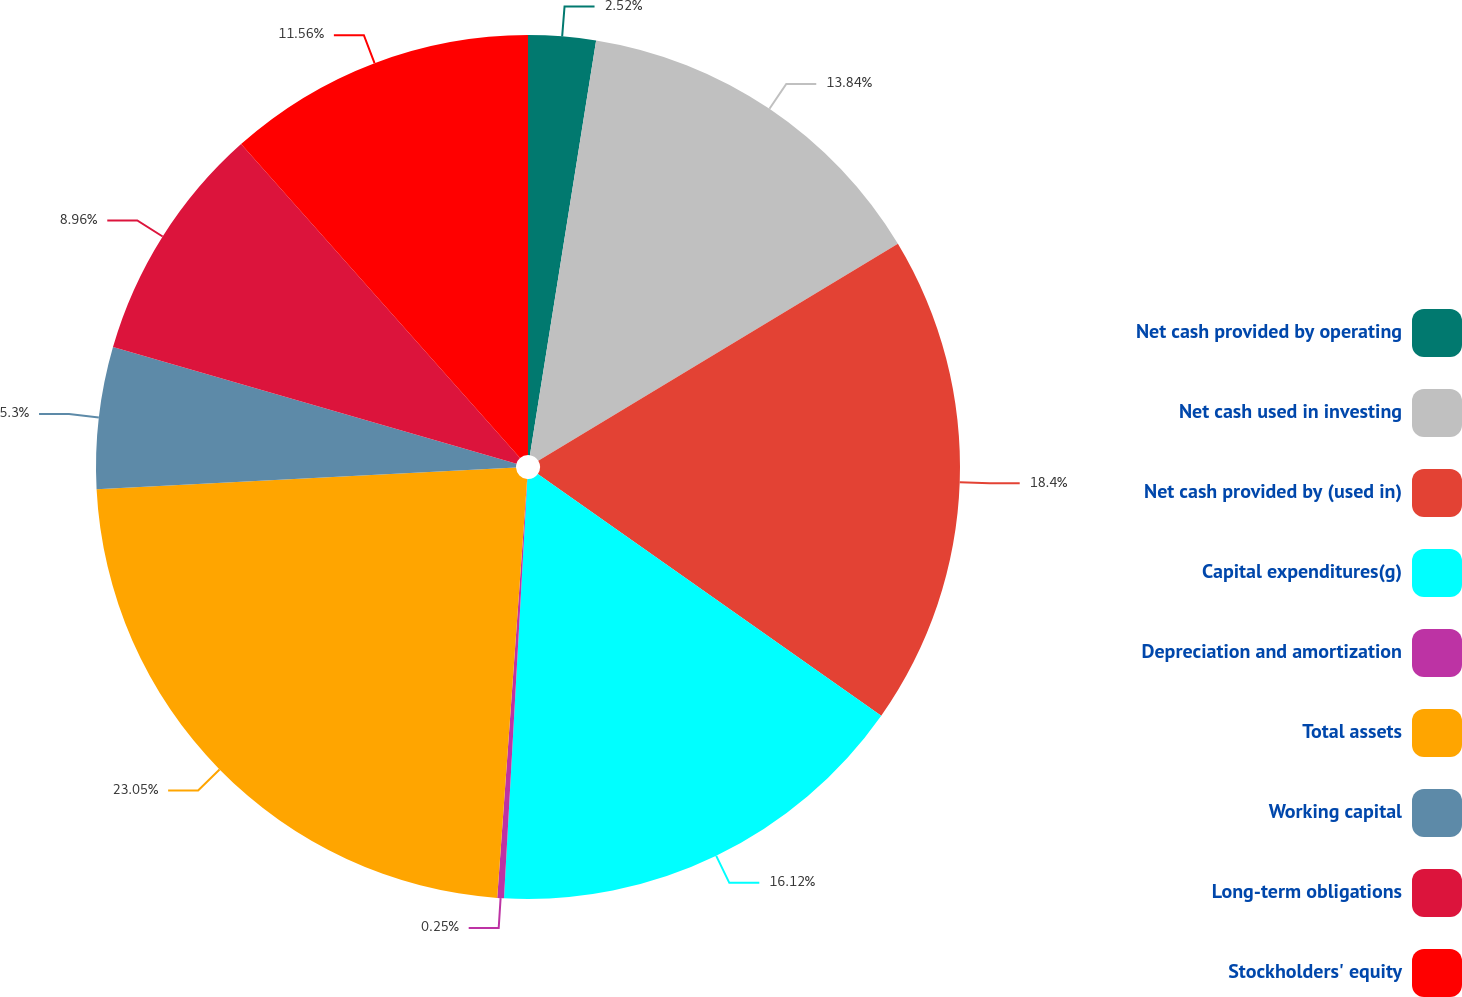Convert chart. <chart><loc_0><loc_0><loc_500><loc_500><pie_chart><fcel>Net cash provided by operating<fcel>Net cash used in investing<fcel>Net cash provided by (used in)<fcel>Capital expenditures(g)<fcel>Depreciation and amortization<fcel>Total assets<fcel>Working capital<fcel>Long-term obligations<fcel>Stockholders' equity<nl><fcel>2.52%<fcel>13.84%<fcel>18.4%<fcel>16.12%<fcel>0.25%<fcel>23.04%<fcel>5.3%<fcel>8.96%<fcel>11.56%<nl></chart> 